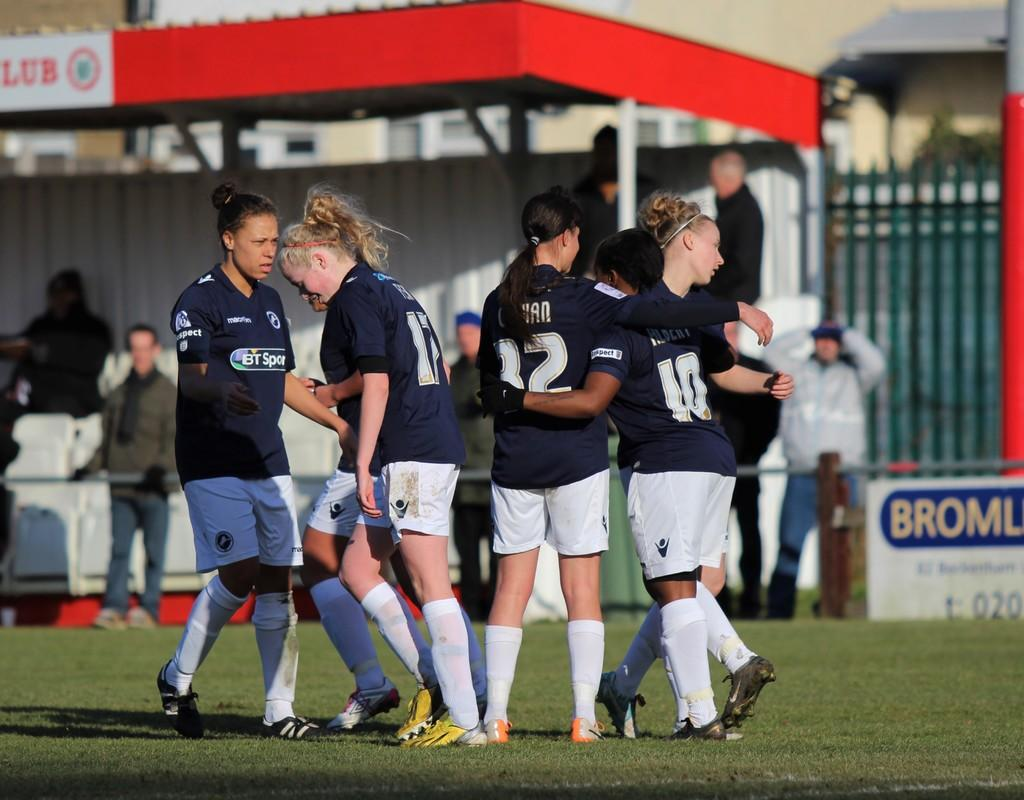<image>
Describe the image concisely. A girl wears number 10 on the soccer field. 